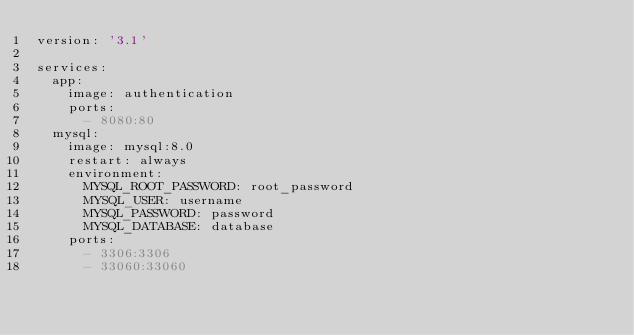Convert code to text. <code><loc_0><loc_0><loc_500><loc_500><_YAML_>version: '3.1'

services:
  app:
    image: authentication
    ports: 
      - 8080:80
  mysql:
    image: mysql:8.0
    restart: always
    environment:
      MYSQL_ROOT_PASSWORD: root_password
      MYSQL_USER: username
      MYSQL_PASSWORD: password
      MYSQL_DATABASE: database
    ports: 
      - 3306:3306
      - 33060:33060
    </code> 